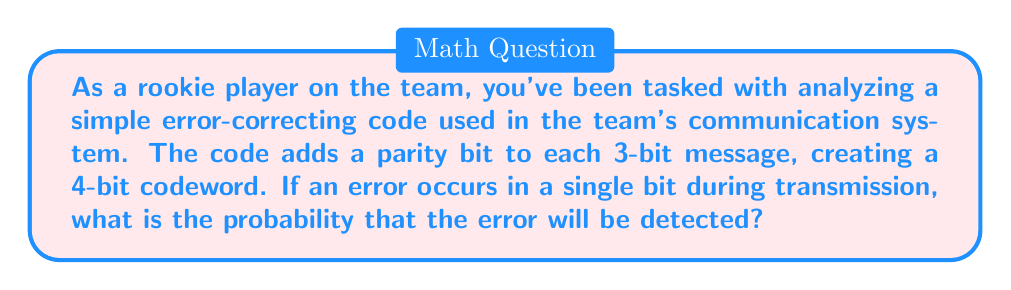Provide a solution to this math problem. Let's approach this step-by-step:

1) First, let's understand how the parity bit works:
   - The parity bit is set to 0 if the number of 1s in the original 3-bit message is even.
   - The parity bit is set to 1 if the number of 1s in the original 3-bit message is odd.

2) This system can detect any single-bit error because it will change the parity of the message.

3) Now, let's consider all possible scenarios:
   - There are $2^4 = 16$ possible 4-bit codewords.
   - Each codeword has 4 bits that could potentially be flipped.

4) When a single-bit error occurs:
   - If the error is in any of the 4 bits, it will be detected.
   - The probability of detecting the error is thus 4/4 = 1.

5) However, this code cannot detect all types of errors. For example:
   - If two bits are flipped, the parity might remain the same, and the error would go undetected.

6) The probability of detection is calculated as:

   $$P(\text{detection}) = \frac{\text{Number of detectable error patterns}}{\text{Total number of possible error patterns}}$$

7) In this case:
   - Number of detectable error patterns = 4 (any single bit flip)
   - Total number of possible error patterns = 4 (assuming only single-bit errors occur)

8) Therefore:

   $$P(\text{detection}) = \frac{4}{4} = 1$$

This means that if a single-bit error occurs, it will always be detected.
Answer: The probability that a single-bit error will be detected is 1 (or 100%). 